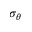<formula> <loc_0><loc_0><loc_500><loc_500>\sigma _ { \theta }</formula> 